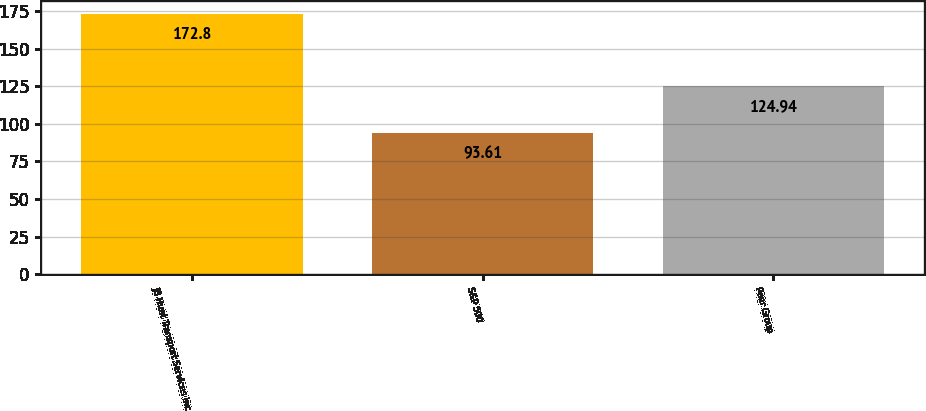Convert chart to OTSL. <chart><loc_0><loc_0><loc_500><loc_500><bar_chart><fcel>JB Hunt Transport Services Inc<fcel>S&P 500<fcel>Peer Group<nl><fcel>172.8<fcel>93.61<fcel>124.94<nl></chart> 